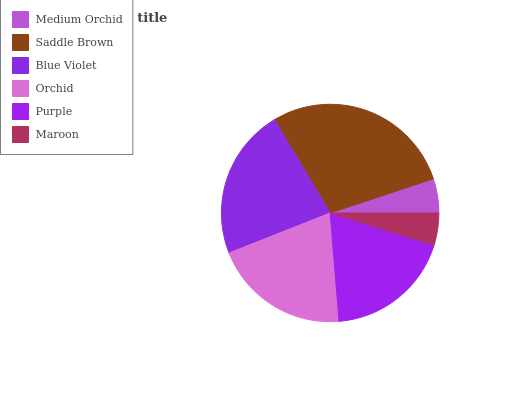Is Maroon the minimum?
Answer yes or no. Yes. Is Saddle Brown the maximum?
Answer yes or no. Yes. Is Blue Violet the minimum?
Answer yes or no. No. Is Blue Violet the maximum?
Answer yes or no. No. Is Saddle Brown greater than Blue Violet?
Answer yes or no. Yes. Is Blue Violet less than Saddle Brown?
Answer yes or no. Yes. Is Blue Violet greater than Saddle Brown?
Answer yes or no. No. Is Saddle Brown less than Blue Violet?
Answer yes or no. No. Is Orchid the high median?
Answer yes or no. Yes. Is Purple the low median?
Answer yes or no. Yes. Is Medium Orchid the high median?
Answer yes or no. No. Is Blue Violet the low median?
Answer yes or no. No. 